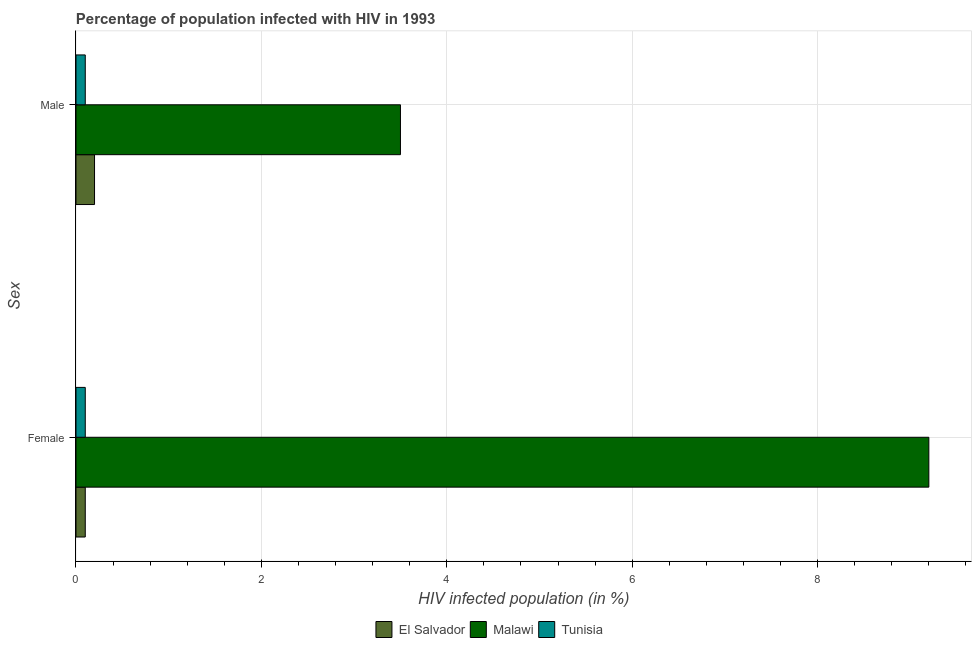How many different coloured bars are there?
Give a very brief answer. 3. How many groups of bars are there?
Provide a succinct answer. 2. Are the number of bars on each tick of the Y-axis equal?
Provide a short and direct response. Yes. How many bars are there on the 1st tick from the top?
Provide a succinct answer. 3. How many bars are there on the 1st tick from the bottom?
Your answer should be very brief. 3. What is the percentage of females who are infected with hiv in Tunisia?
Keep it short and to the point. 0.1. Across all countries, what is the minimum percentage of females who are infected with hiv?
Your response must be concise. 0.1. In which country was the percentage of females who are infected with hiv maximum?
Your response must be concise. Malawi. In which country was the percentage of males who are infected with hiv minimum?
Keep it short and to the point. Tunisia. What is the total percentage of females who are infected with hiv in the graph?
Offer a very short reply. 9.4. What is the average percentage of females who are infected with hiv per country?
Your answer should be very brief. 3.13. In how many countries, is the percentage of males who are infected with hiv greater than 4.4 %?
Keep it short and to the point. 0. What is the ratio of the percentage of males who are infected with hiv in Tunisia to that in Malawi?
Keep it short and to the point. 0.03. In how many countries, is the percentage of males who are infected with hiv greater than the average percentage of males who are infected with hiv taken over all countries?
Offer a terse response. 1. What does the 3rd bar from the top in Male represents?
Keep it short and to the point. El Salvador. What does the 2nd bar from the bottom in Male represents?
Your answer should be compact. Malawi. How many countries are there in the graph?
Your answer should be very brief. 3. Are the values on the major ticks of X-axis written in scientific E-notation?
Your answer should be compact. No. Does the graph contain any zero values?
Make the answer very short. No. Where does the legend appear in the graph?
Your answer should be very brief. Bottom center. How are the legend labels stacked?
Offer a very short reply. Horizontal. What is the title of the graph?
Ensure brevity in your answer.  Percentage of population infected with HIV in 1993. Does "Northern Mariana Islands" appear as one of the legend labels in the graph?
Make the answer very short. No. What is the label or title of the X-axis?
Your answer should be compact. HIV infected population (in %). What is the label or title of the Y-axis?
Make the answer very short. Sex. What is the HIV infected population (in %) in El Salvador in Female?
Ensure brevity in your answer.  0.1. What is the HIV infected population (in %) of Tunisia in Female?
Make the answer very short. 0.1. What is the HIV infected population (in %) of Malawi in Male?
Your answer should be compact. 3.5. What is the HIV infected population (in %) in Tunisia in Male?
Keep it short and to the point. 0.1. Across all Sex, what is the maximum HIV infected population (in %) in El Salvador?
Make the answer very short. 0.2. Across all Sex, what is the maximum HIV infected population (in %) in Tunisia?
Your answer should be very brief. 0.1. Across all Sex, what is the minimum HIV infected population (in %) of El Salvador?
Your response must be concise. 0.1. What is the total HIV infected population (in %) in El Salvador in the graph?
Provide a short and direct response. 0.3. What is the total HIV infected population (in %) in Malawi in the graph?
Offer a very short reply. 12.7. What is the total HIV infected population (in %) of Tunisia in the graph?
Provide a succinct answer. 0.2. What is the difference between the HIV infected population (in %) of El Salvador in Female and that in Male?
Keep it short and to the point. -0.1. What is the difference between the HIV infected population (in %) of Tunisia in Female and that in Male?
Make the answer very short. 0. What is the difference between the HIV infected population (in %) of Malawi in Female and the HIV infected population (in %) of Tunisia in Male?
Give a very brief answer. 9.1. What is the average HIV infected population (in %) in Malawi per Sex?
Your response must be concise. 6.35. What is the difference between the HIV infected population (in %) of El Salvador and HIV infected population (in %) of Tunisia in Female?
Keep it short and to the point. 0. What is the ratio of the HIV infected population (in %) of Malawi in Female to that in Male?
Provide a succinct answer. 2.63. What is the difference between the highest and the second highest HIV infected population (in %) in Malawi?
Ensure brevity in your answer.  5.7. What is the difference between the highest and the lowest HIV infected population (in %) in El Salvador?
Make the answer very short. 0.1. What is the difference between the highest and the lowest HIV infected population (in %) of Malawi?
Your response must be concise. 5.7. What is the difference between the highest and the lowest HIV infected population (in %) of Tunisia?
Offer a very short reply. 0. 